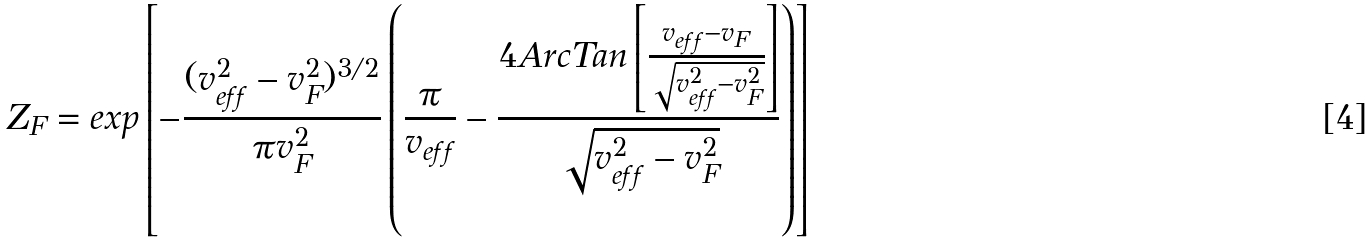Convert formula to latex. <formula><loc_0><loc_0><loc_500><loc_500>Z _ { F } = e x p \left [ - \frac { ( v _ { e f f } ^ { 2 } - v ^ { 2 } _ { F } ) ^ { 3 / 2 } } { \pi v ^ { 2 } _ { F } } \left ( \frac { \pi } { v _ { e f f } } - \frac { 4 A r c T a n \left [ \frac { v _ { e f f } - v _ { F } } { \sqrt { v _ { e f f } ^ { 2 } - v _ { F } ^ { 2 } } } \right ] } { \sqrt { v _ { e f f } ^ { 2 } - v _ { F } ^ { 2 } } } \right ) \right ]</formula> 